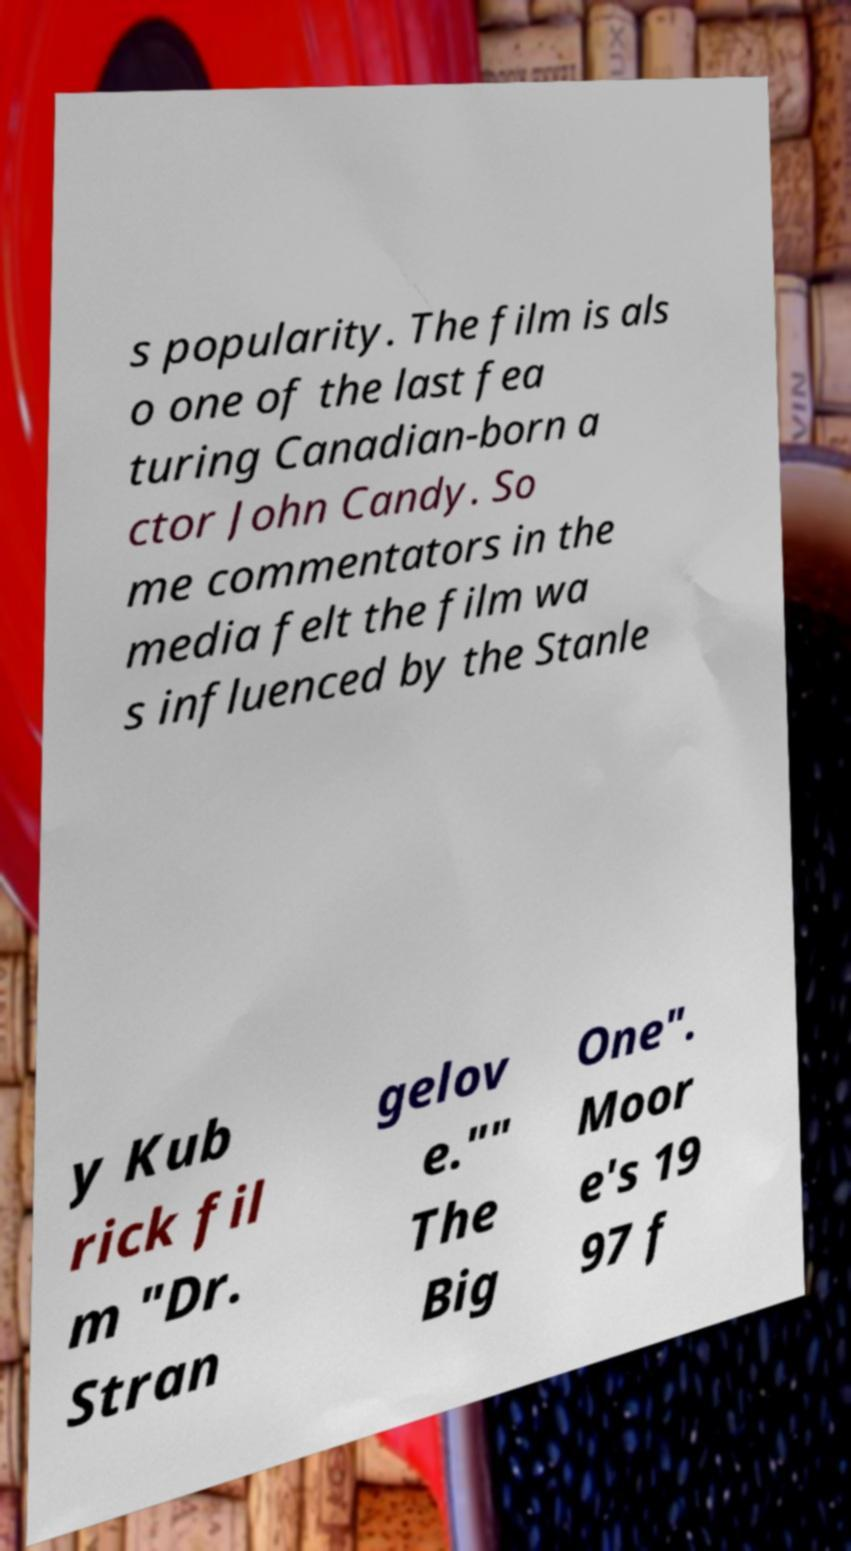Please identify and transcribe the text found in this image. s popularity. The film is als o one of the last fea turing Canadian-born a ctor John Candy. So me commentators in the media felt the film wa s influenced by the Stanle y Kub rick fil m "Dr. Stran gelov e."" The Big One". Moor e's 19 97 f 